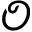Convert formula to latex. <formula><loc_0><loc_0><loc_500><loc_500>\mathcal { O }</formula> 